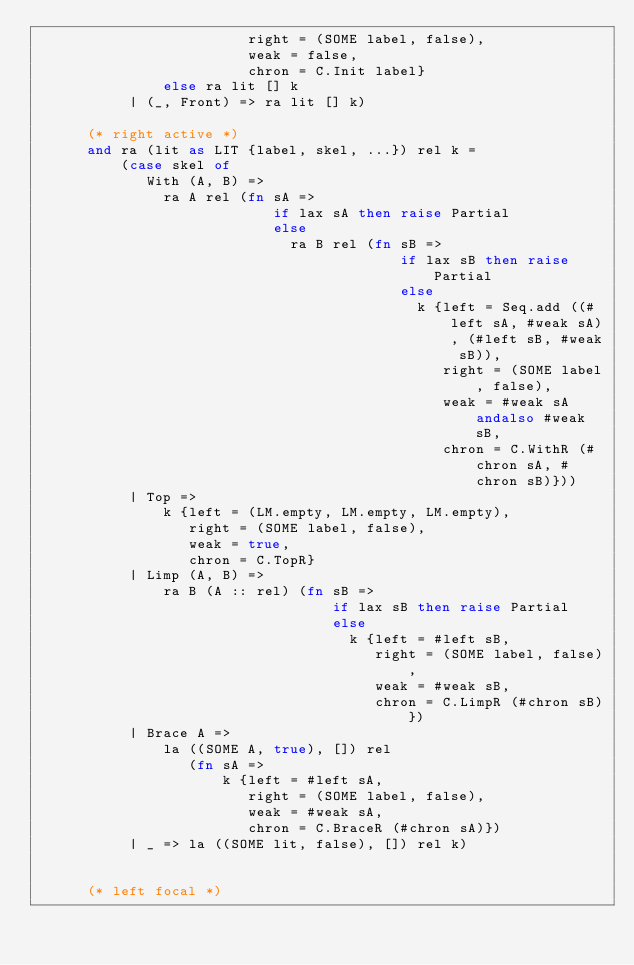Convert code to text. <code><loc_0><loc_0><loc_500><loc_500><_SML_>                         right = (SOME label, false),
                         weak = false,
                         chron = C.Init label}
               else ra lit [] k
           | (_, Front) => ra lit [] k)

      (* right active *)
      and ra (lit as LIT {label, skel, ...}) rel k =
          (case skel of
             With (A, B) => 
               ra A rel (fn sA =>
                            if lax sA then raise Partial
                            else 
                              ra B rel (fn sB => 
                                           if lax sB then raise Partial
                                           else 
                                             k {left = Seq.add ((#left sA, #weak sA), (#left sB, #weak sB)),
                                                right = (SOME label, false),
                                                weak = #weak sA andalso #weak sB,
                                                chron = C.WithR (#chron sA, #chron sB)}))
           | Top => 
               k {left = (LM.empty, LM.empty, LM.empty),
                  right = (SOME label, false),
                  weak = true,
                  chron = C.TopR}
           | Limp (A, B) => 
               ra B (A :: rel) (fn sB =>
                                   if lax sB then raise Partial
                                   else 
                                     k {left = #left sB,
                                        right = (SOME label, false),
                                        weak = #weak sB,
                                        chron = C.LimpR (#chron sB)})
           | Brace A => 
               la ((SOME A, true), []) rel
                  (fn sA =>
                      k {left = #left sA,
                         right = (SOME label, false),
                         weak = #weak sA,
                         chron = C.BraceR (#chron sA)})
           | _ => la ((SOME lit, false), []) rel k)


      (* left focal *)</code> 